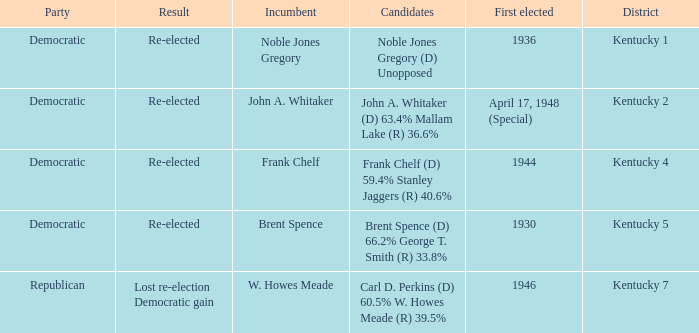List all candidates in the democratic party where the election had the incumbent Frank Chelf running. Frank Chelf (D) 59.4% Stanley Jaggers (R) 40.6%. 